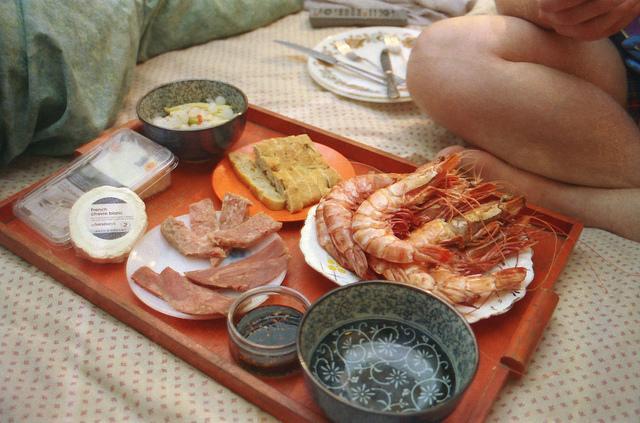How many dining tables can you see?
Give a very brief answer. 2. How many bowls are in the photo?
Give a very brief answer. 3. 